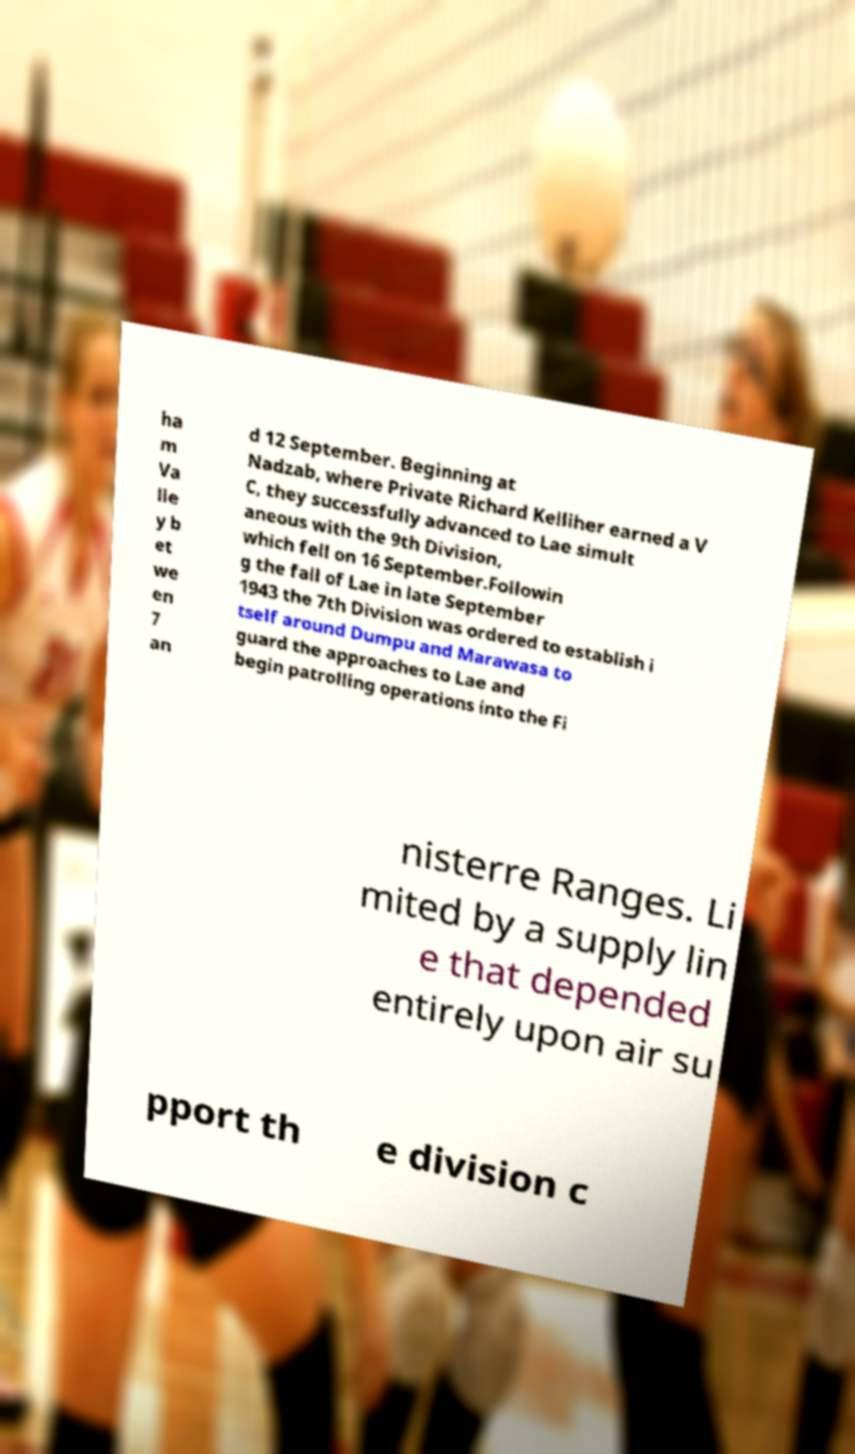There's text embedded in this image that I need extracted. Can you transcribe it verbatim? ha m Va lle y b et we en 7 an d 12 September. Beginning at Nadzab, where Private Richard Kelliher earned a V C, they successfully advanced to Lae simult aneous with the 9th Division, which fell on 16 September.Followin g the fall of Lae in late September 1943 the 7th Division was ordered to establish i tself around Dumpu and Marawasa to guard the approaches to Lae and begin patrolling operations into the Fi nisterre Ranges. Li mited by a supply lin e that depended entirely upon air su pport th e division c 